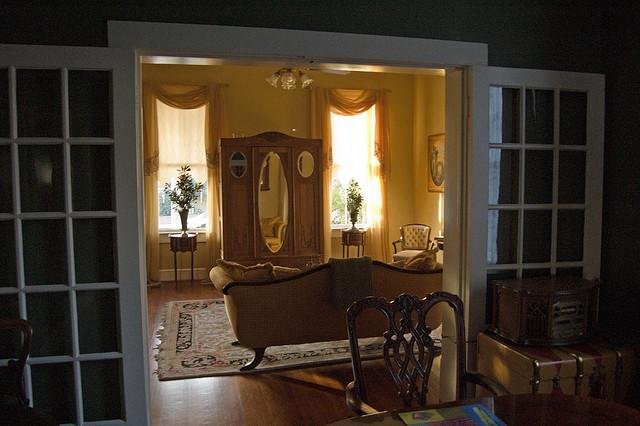What is at the far end of the room?

Choices:
A) mirror
B) dog
C) cat
D) baby mirror 